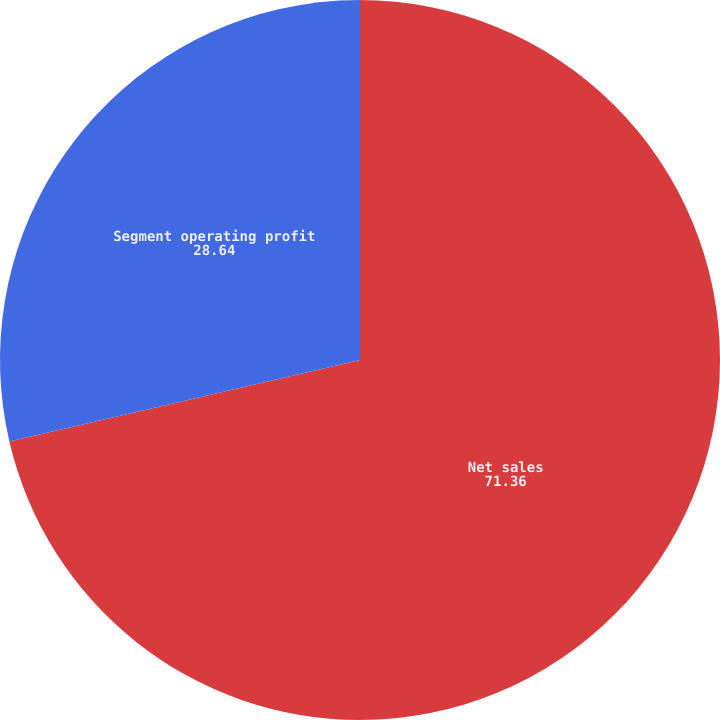Convert chart to OTSL. <chart><loc_0><loc_0><loc_500><loc_500><pie_chart><fcel>Net sales<fcel>Segment operating profit<nl><fcel>71.36%<fcel>28.64%<nl></chart> 